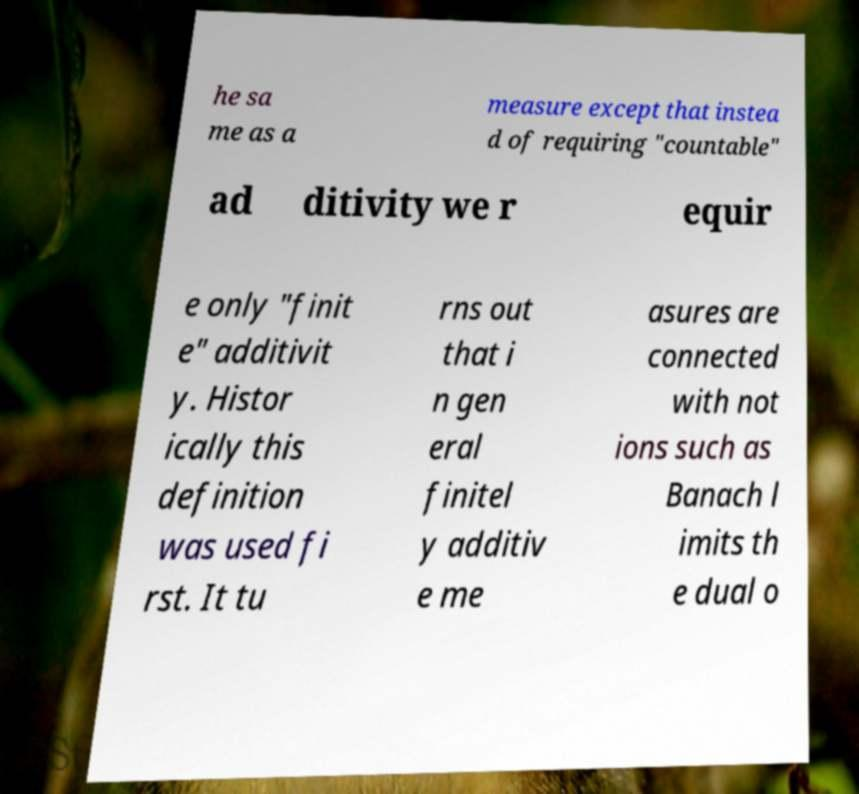Can you read and provide the text displayed in the image?This photo seems to have some interesting text. Can you extract and type it out for me? he sa me as a measure except that instea d of requiring "countable" ad ditivity we r equir e only "finit e" additivit y. Histor ically this definition was used fi rst. It tu rns out that i n gen eral finitel y additiv e me asures are connected with not ions such as Banach l imits th e dual o 